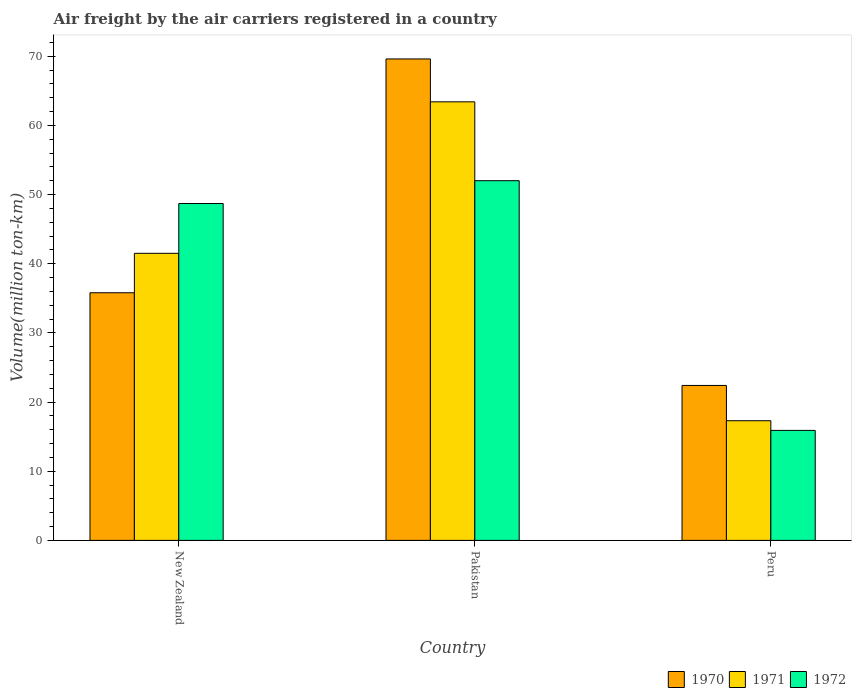How many groups of bars are there?
Provide a short and direct response. 3. Are the number of bars per tick equal to the number of legend labels?
Give a very brief answer. Yes. Are the number of bars on each tick of the X-axis equal?
Your answer should be very brief. Yes. How many bars are there on the 2nd tick from the right?
Give a very brief answer. 3. What is the label of the 3rd group of bars from the left?
Provide a succinct answer. Peru. In how many cases, is the number of bars for a given country not equal to the number of legend labels?
Your answer should be very brief. 0. What is the volume of the air carriers in 1970 in New Zealand?
Your answer should be very brief. 35.8. Across all countries, what is the minimum volume of the air carriers in 1971?
Provide a short and direct response. 17.3. In which country was the volume of the air carriers in 1971 maximum?
Provide a succinct answer. Pakistan. What is the total volume of the air carriers in 1971 in the graph?
Ensure brevity in your answer.  122.2. What is the difference between the volume of the air carriers in 1972 in New Zealand and that in Pakistan?
Offer a very short reply. -3.3. What is the difference between the volume of the air carriers in 1972 in Peru and the volume of the air carriers in 1971 in Pakistan?
Make the answer very short. -47.5. What is the average volume of the air carriers in 1970 per country?
Ensure brevity in your answer.  42.6. What is the difference between the volume of the air carriers of/in 1972 and volume of the air carriers of/in 1971 in Pakistan?
Provide a succinct answer. -11.4. In how many countries, is the volume of the air carriers in 1970 greater than 28 million ton-km?
Make the answer very short. 2. What is the ratio of the volume of the air carriers in 1972 in Pakistan to that in Peru?
Your answer should be compact. 3.27. Is the volume of the air carriers in 1971 in Pakistan less than that in Peru?
Give a very brief answer. No. Is the difference between the volume of the air carriers in 1972 in Pakistan and Peru greater than the difference between the volume of the air carriers in 1971 in Pakistan and Peru?
Keep it short and to the point. No. What is the difference between the highest and the second highest volume of the air carriers in 1972?
Give a very brief answer. -3.3. What is the difference between the highest and the lowest volume of the air carriers in 1970?
Your response must be concise. 47.2. In how many countries, is the volume of the air carriers in 1970 greater than the average volume of the air carriers in 1970 taken over all countries?
Your answer should be very brief. 1. Is the sum of the volume of the air carriers in 1971 in Pakistan and Peru greater than the maximum volume of the air carriers in 1970 across all countries?
Provide a succinct answer. Yes. What does the 2nd bar from the right in New Zealand represents?
Provide a succinct answer. 1971. Is it the case that in every country, the sum of the volume of the air carriers in 1971 and volume of the air carriers in 1970 is greater than the volume of the air carriers in 1972?
Your response must be concise. Yes. How many bars are there?
Your answer should be very brief. 9. How many countries are there in the graph?
Keep it short and to the point. 3. Does the graph contain any zero values?
Offer a terse response. No. Where does the legend appear in the graph?
Your response must be concise. Bottom right. How are the legend labels stacked?
Offer a terse response. Horizontal. What is the title of the graph?
Ensure brevity in your answer.  Air freight by the air carriers registered in a country. Does "2011" appear as one of the legend labels in the graph?
Keep it short and to the point. No. What is the label or title of the Y-axis?
Ensure brevity in your answer.  Volume(million ton-km). What is the Volume(million ton-km) of 1970 in New Zealand?
Make the answer very short. 35.8. What is the Volume(million ton-km) in 1971 in New Zealand?
Ensure brevity in your answer.  41.5. What is the Volume(million ton-km) in 1972 in New Zealand?
Keep it short and to the point. 48.7. What is the Volume(million ton-km) of 1970 in Pakistan?
Provide a short and direct response. 69.6. What is the Volume(million ton-km) of 1971 in Pakistan?
Provide a short and direct response. 63.4. What is the Volume(million ton-km) of 1970 in Peru?
Offer a terse response. 22.4. What is the Volume(million ton-km) in 1971 in Peru?
Offer a very short reply. 17.3. What is the Volume(million ton-km) of 1972 in Peru?
Your response must be concise. 15.9. Across all countries, what is the maximum Volume(million ton-km) of 1970?
Offer a terse response. 69.6. Across all countries, what is the maximum Volume(million ton-km) of 1971?
Your answer should be compact. 63.4. Across all countries, what is the maximum Volume(million ton-km) in 1972?
Provide a short and direct response. 52. Across all countries, what is the minimum Volume(million ton-km) in 1970?
Make the answer very short. 22.4. Across all countries, what is the minimum Volume(million ton-km) of 1971?
Provide a short and direct response. 17.3. Across all countries, what is the minimum Volume(million ton-km) in 1972?
Offer a terse response. 15.9. What is the total Volume(million ton-km) of 1970 in the graph?
Ensure brevity in your answer.  127.8. What is the total Volume(million ton-km) of 1971 in the graph?
Make the answer very short. 122.2. What is the total Volume(million ton-km) of 1972 in the graph?
Your answer should be very brief. 116.6. What is the difference between the Volume(million ton-km) in 1970 in New Zealand and that in Pakistan?
Provide a short and direct response. -33.8. What is the difference between the Volume(million ton-km) in 1971 in New Zealand and that in Pakistan?
Keep it short and to the point. -21.9. What is the difference between the Volume(million ton-km) in 1971 in New Zealand and that in Peru?
Offer a very short reply. 24.2. What is the difference between the Volume(million ton-km) in 1972 in New Zealand and that in Peru?
Your response must be concise. 32.8. What is the difference between the Volume(million ton-km) in 1970 in Pakistan and that in Peru?
Your answer should be very brief. 47.2. What is the difference between the Volume(million ton-km) of 1971 in Pakistan and that in Peru?
Your answer should be compact. 46.1. What is the difference between the Volume(million ton-km) of 1972 in Pakistan and that in Peru?
Provide a succinct answer. 36.1. What is the difference between the Volume(million ton-km) in 1970 in New Zealand and the Volume(million ton-km) in 1971 in Pakistan?
Your answer should be very brief. -27.6. What is the difference between the Volume(million ton-km) in 1970 in New Zealand and the Volume(million ton-km) in 1972 in Pakistan?
Offer a very short reply. -16.2. What is the difference between the Volume(million ton-km) of 1971 in New Zealand and the Volume(million ton-km) of 1972 in Pakistan?
Give a very brief answer. -10.5. What is the difference between the Volume(million ton-km) of 1970 in New Zealand and the Volume(million ton-km) of 1972 in Peru?
Offer a very short reply. 19.9. What is the difference between the Volume(million ton-km) of 1971 in New Zealand and the Volume(million ton-km) of 1972 in Peru?
Offer a terse response. 25.6. What is the difference between the Volume(million ton-km) of 1970 in Pakistan and the Volume(million ton-km) of 1971 in Peru?
Offer a very short reply. 52.3. What is the difference between the Volume(million ton-km) of 1970 in Pakistan and the Volume(million ton-km) of 1972 in Peru?
Your response must be concise. 53.7. What is the difference between the Volume(million ton-km) of 1971 in Pakistan and the Volume(million ton-km) of 1972 in Peru?
Ensure brevity in your answer.  47.5. What is the average Volume(million ton-km) of 1970 per country?
Your answer should be compact. 42.6. What is the average Volume(million ton-km) in 1971 per country?
Your answer should be compact. 40.73. What is the average Volume(million ton-km) in 1972 per country?
Offer a terse response. 38.87. What is the difference between the Volume(million ton-km) of 1970 and Volume(million ton-km) of 1971 in Pakistan?
Provide a succinct answer. 6.2. What is the difference between the Volume(million ton-km) in 1971 and Volume(million ton-km) in 1972 in Peru?
Provide a short and direct response. 1.4. What is the ratio of the Volume(million ton-km) in 1970 in New Zealand to that in Pakistan?
Make the answer very short. 0.51. What is the ratio of the Volume(million ton-km) in 1971 in New Zealand to that in Pakistan?
Offer a terse response. 0.65. What is the ratio of the Volume(million ton-km) in 1972 in New Zealand to that in Pakistan?
Your answer should be compact. 0.94. What is the ratio of the Volume(million ton-km) in 1970 in New Zealand to that in Peru?
Provide a short and direct response. 1.6. What is the ratio of the Volume(million ton-km) in 1971 in New Zealand to that in Peru?
Ensure brevity in your answer.  2.4. What is the ratio of the Volume(million ton-km) in 1972 in New Zealand to that in Peru?
Keep it short and to the point. 3.06. What is the ratio of the Volume(million ton-km) of 1970 in Pakistan to that in Peru?
Keep it short and to the point. 3.11. What is the ratio of the Volume(million ton-km) of 1971 in Pakistan to that in Peru?
Your response must be concise. 3.66. What is the ratio of the Volume(million ton-km) of 1972 in Pakistan to that in Peru?
Offer a terse response. 3.27. What is the difference between the highest and the second highest Volume(million ton-km) in 1970?
Offer a terse response. 33.8. What is the difference between the highest and the second highest Volume(million ton-km) in 1971?
Offer a terse response. 21.9. What is the difference between the highest and the second highest Volume(million ton-km) of 1972?
Provide a succinct answer. 3.3. What is the difference between the highest and the lowest Volume(million ton-km) in 1970?
Keep it short and to the point. 47.2. What is the difference between the highest and the lowest Volume(million ton-km) of 1971?
Your answer should be compact. 46.1. What is the difference between the highest and the lowest Volume(million ton-km) in 1972?
Make the answer very short. 36.1. 